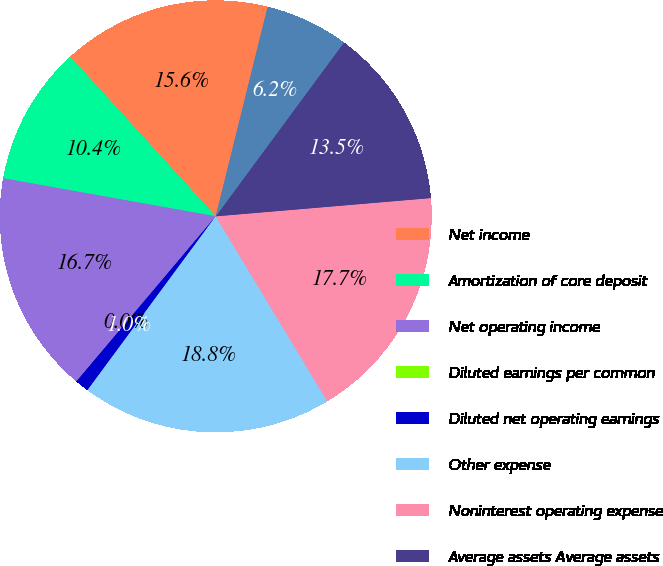Convert chart to OTSL. <chart><loc_0><loc_0><loc_500><loc_500><pie_chart><fcel>Net income<fcel>Amortization of core deposit<fcel>Net operating income<fcel>Diluted earnings per common<fcel>Diluted net operating earnings<fcel>Other expense<fcel>Noninterest operating expense<fcel>Average assets Average assets<fcel>Goodwill<nl><fcel>15.62%<fcel>10.42%<fcel>16.67%<fcel>0.0%<fcel>1.04%<fcel>18.75%<fcel>17.71%<fcel>13.54%<fcel>6.25%<nl></chart> 